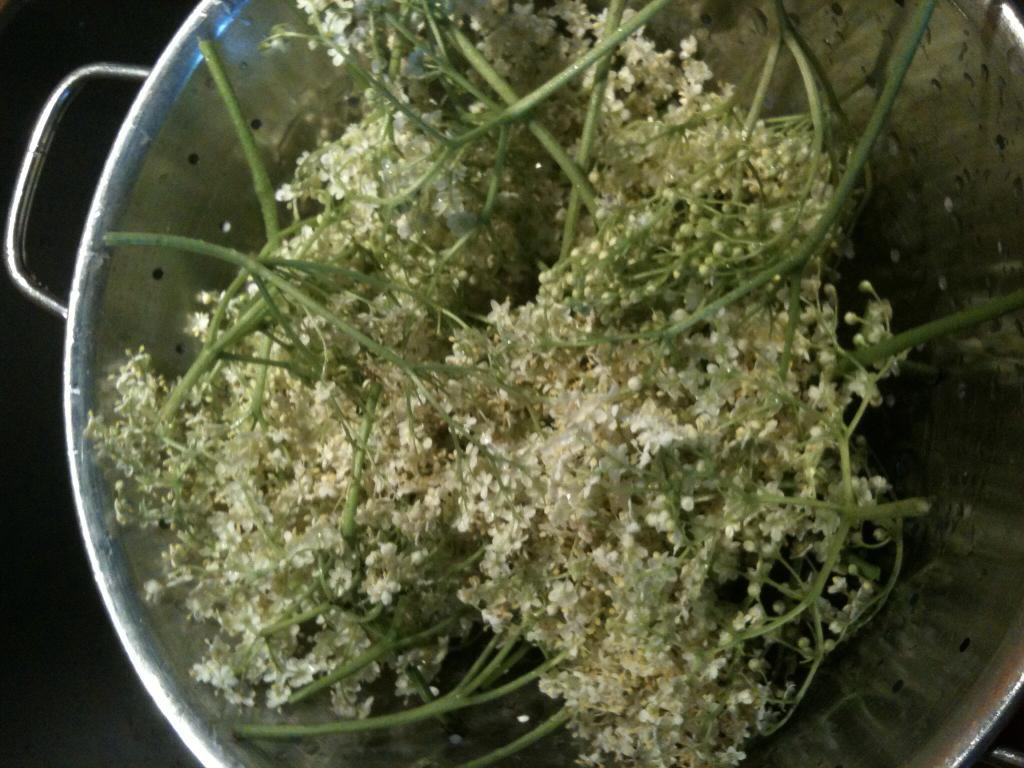What object is present in the image that is made of steel? There is a steel bucket in the image. What is inside the steel bucket? The steel bucket contains coriander seeds. Where is the area of darkness located in the image? There is darkness in the bottom left corner of the image. How many houses can be seen in the image? There are no houses present in the image. What time of day is depicted in the image? The time of day cannot be determined from the image, as there are no specific indicators of time. 